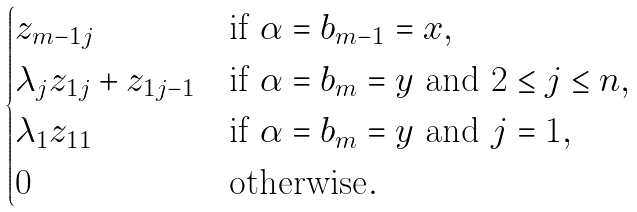Convert formula to latex. <formula><loc_0><loc_0><loc_500><loc_500>\begin{cases} z _ { m - 1 j } & \text {if $\alpha = b_{m-1} = x$} , \\ \lambda _ { j } z _ { 1 j } + z _ { 1 j - 1 } & \text {if $\alpha = b_{m} = y$ and $2 \leq j \leq n$} , \\ \lambda _ { 1 } z _ { 1 1 } & \text {if $\alpha = b_{m} = y$ and $j=1$} , \\ 0 & \text {otherwise} . \end{cases}</formula> 